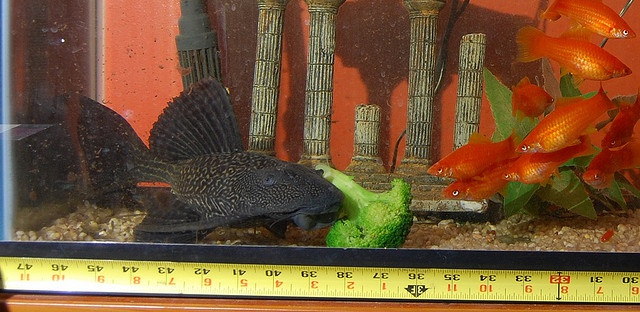Describe the objects in this image and their specific colors. I can see a broccoli in blue, green, lightgreen, and darkgreen tones in this image. 